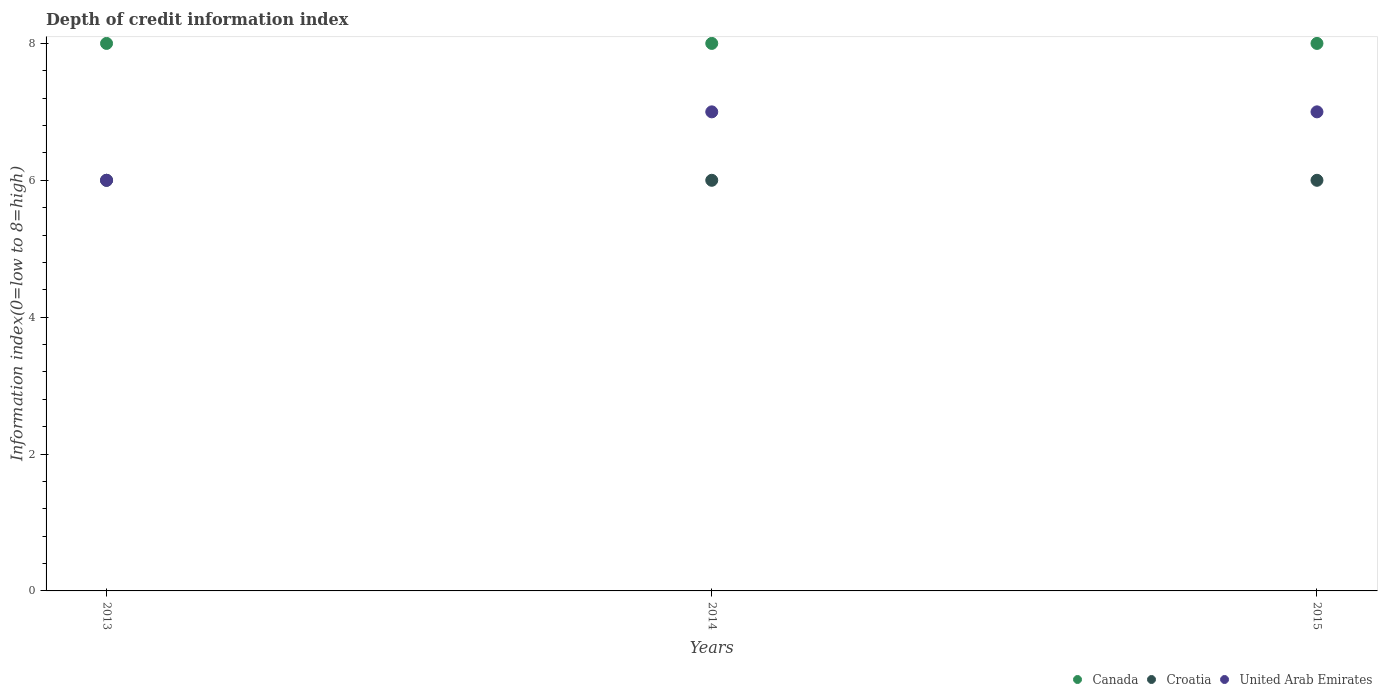What is the information index in Canada in 2013?
Give a very brief answer. 8. Across all years, what is the maximum information index in Canada?
Offer a very short reply. 8. Across all years, what is the minimum information index in Canada?
Your response must be concise. 8. In which year was the information index in Canada maximum?
Your answer should be very brief. 2013. What is the total information index in Croatia in the graph?
Offer a very short reply. 18. What is the difference between the information index in Croatia in 2013 and that in 2015?
Provide a succinct answer. 0. What is the difference between the information index in United Arab Emirates in 2015 and the information index in Croatia in 2013?
Make the answer very short. 1. Is the information index in Croatia in 2014 less than that in 2015?
Keep it short and to the point. No. Is the difference between the information index in United Arab Emirates in 2014 and 2015 greater than the difference between the information index in Croatia in 2014 and 2015?
Ensure brevity in your answer.  No. What is the difference between the highest and the lowest information index in United Arab Emirates?
Your answer should be very brief. 1. In how many years, is the information index in United Arab Emirates greater than the average information index in United Arab Emirates taken over all years?
Your answer should be compact. 2. Is the sum of the information index in Canada in 2014 and 2015 greater than the maximum information index in Croatia across all years?
Your answer should be very brief. Yes. Is it the case that in every year, the sum of the information index in Canada and information index in Croatia  is greater than the information index in United Arab Emirates?
Keep it short and to the point. Yes. Does the information index in United Arab Emirates monotonically increase over the years?
Your answer should be very brief. No. Is the information index in Canada strictly greater than the information index in United Arab Emirates over the years?
Your answer should be very brief. Yes. How many years are there in the graph?
Offer a terse response. 3. What is the difference between two consecutive major ticks on the Y-axis?
Make the answer very short. 2. Does the graph contain any zero values?
Keep it short and to the point. No. Does the graph contain grids?
Offer a very short reply. No. How many legend labels are there?
Give a very brief answer. 3. How are the legend labels stacked?
Offer a terse response. Horizontal. What is the title of the graph?
Ensure brevity in your answer.  Depth of credit information index. Does "American Samoa" appear as one of the legend labels in the graph?
Give a very brief answer. No. What is the label or title of the Y-axis?
Your answer should be very brief. Information index(0=low to 8=high). What is the Information index(0=low to 8=high) of Croatia in 2013?
Your answer should be very brief. 6. What is the Information index(0=low to 8=high) in United Arab Emirates in 2013?
Keep it short and to the point. 6. What is the Information index(0=low to 8=high) in Croatia in 2014?
Provide a succinct answer. 6. What is the Information index(0=low to 8=high) of United Arab Emirates in 2014?
Your response must be concise. 7. What is the Information index(0=low to 8=high) in Croatia in 2015?
Provide a succinct answer. 6. Across all years, what is the maximum Information index(0=low to 8=high) in Croatia?
Offer a very short reply. 6. Across all years, what is the maximum Information index(0=low to 8=high) in United Arab Emirates?
Give a very brief answer. 7. Across all years, what is the minimum Information index(0=low to 8=high) of Canada?
Your answer should be very brief. 8. Across all years, what is the minimum Information index(0=low to 8=high) of United Arab Emirates?
Offer a very short reply. 6. What is the total Information index(0=low to 8=high) in United Arab Emirates in the graph?
Make the answer very short. 20. What is the difference between the Information index(0=low to 8=high) of Croatia in 2013 and that in 2014?
Make the answer very short. 0. What is the difference between the Information index(0=low to 8=high) in United Arab Emirates in 2013 and that in 2014?
Your response must be concise. -1. What is the difference between the Information index(0=low to 8=high) in Canada in 2013 and that in 2015?
Give a very brief answer. 0. What is the difference between the Information index(0=low to 8=high) in Croatia in 2013 and that in 2015?
Provide a short and direct response. 0. What is the difference between the Information index(0=low to 8=high) in United Arab Emirates in 2013 and that in 2015?
Provide a succinct answer. -1. What is the difference between the Information index(0=low to 8=high) of Canada in 2014 and that in 2015?
Keep it short and to the point. 0. What is the difference between the Information index(0=low to 8=high) in Croatia in 2014 and that in 2015?
Your answer should be compact. 0. What is the difference between the Information index(0=low to 8=high) of United Arab Emirates in 2014 and that in 2015?
Your answer should be very brief. 0. What is the difference between the Information index(0=low to 8=high) in Canada in 2013 and the Information index(0=low to 8=high) in Croatia in 2014?
Ensure brevity in your answer.  2. What is the difference between the Information index(0=low to 8=high) of Croatia in 2013 and the Information index(0=low to 8=high) of United Arab Emirates in 2014?
Give a very brief answer. -1. What is the difference between the Information index(0=low to 8=high) in Croatia in 2013 and the Information index(0=low to 8=high) in United Arab Emirates in 2015?
Make the answer very short. -1. What is the difference between the Information index(0=low to 8=high) of Canada in 2014 and the Information index(0=low to 8=high) of Croatia in 2015?
Your answer should be compact. 2. What is the difference between the Information index(0=low to 8=high) in Croatia in 2014 and the Information index(0=low to 8=high) in United Arab Emirates in 2015?
Make the answer very short. -1. What is the average Information index(0=low to 8=high) in Canada per year?
Offer a terse response. 8. What is the average Information index(0=low to 8=high) in Croatia per year?
Offer a terse response. 6. In the year 2013, what is the difference between the Information index(0=low to 8=high) in Canada and Information index(0=low to 8=high) in United Arab Emirates?
Offer a terse response. 2. In the year 2014, what is the difference between the Information index(0=low to 8=high) in Canada and Information index(0=low to 8=high) in Croatia?
Keep it short and to the point. 2. In the year 2014, what is the difference between the Information index(0=low to 8=high) in Canada and Information index(0=low to 8=high) in United Arab Emirates?
Ensure brevity in your answer.  1. In the year 2015, what is the difference between the Information index(0=low to 8=high) in Canada and Information index(0=low to 8=high) in United Arab Emirates?
Provide a short and direct response. 1. What is the ratio of the Information index(0=low to 8=high) of Canada in 2013 to that in 2014?
Your response must be concise. 1. What is the ratio of the Information index(0=low to 8=high) of United Arab Emirates in 2013 to that in 2014?
Your response must be concise. 0.86. What is the ratio of the Information index(0=low to 8=high) in Canada in 2013 to that in 2015?
Your response must be concise. 1. What is the ratio of the Information index(0=low to 8=high) of Canada in 2014 to that in 2015?
Give a very brief answer. 1. What is the ratio of the Information index(0=low to 8=high) in United Arab Emirates in 2014 to that in 2015?
Your response must be concise. 1. What is the difference between the highest and the second highest Information index(0=low to 8=high) of Canada?
Ensure brevity in your answer.  0. What is the difference between the highest and the second highest Information index(0=low to 8=high) of Croatia?
Provide a succinct answer. 0. What is the difference between the highest and the second highest Information index(0=low to 8=high) in United Arab Emirates?
Provide a succinct answer. 0. What is the difference between the highest and the lowest Information index(0=low to 8=high) in United Arab Emirates?
Give a very brief answer. 1. 